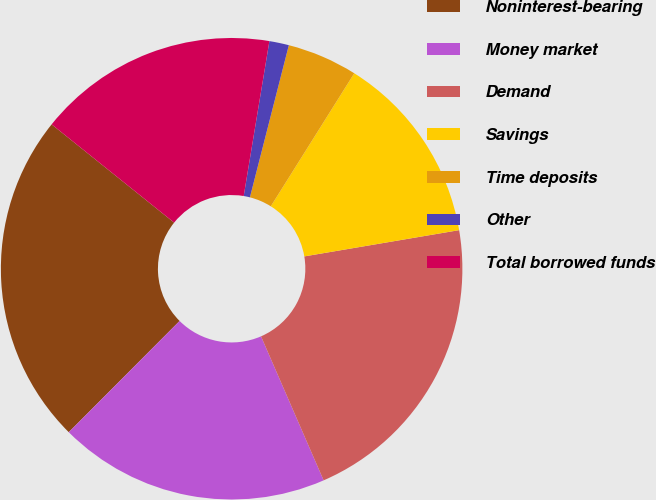<chart> <loc_0><loc_0><loc_500><loc_500><pie_chart><fcel>Noninterest-bearing<fcel>Money market<fcel>Demand<fcel>Savings<fcel>Time deposits<fcel>Other<fcel>Total borrowed funds<nl><fcel>23.29%<fcel>19.0%<fcel>21.15%<fcel>13.41%<fcel>4.93%<fcel>1.37%<fcel>16.86%<nl></chart> 